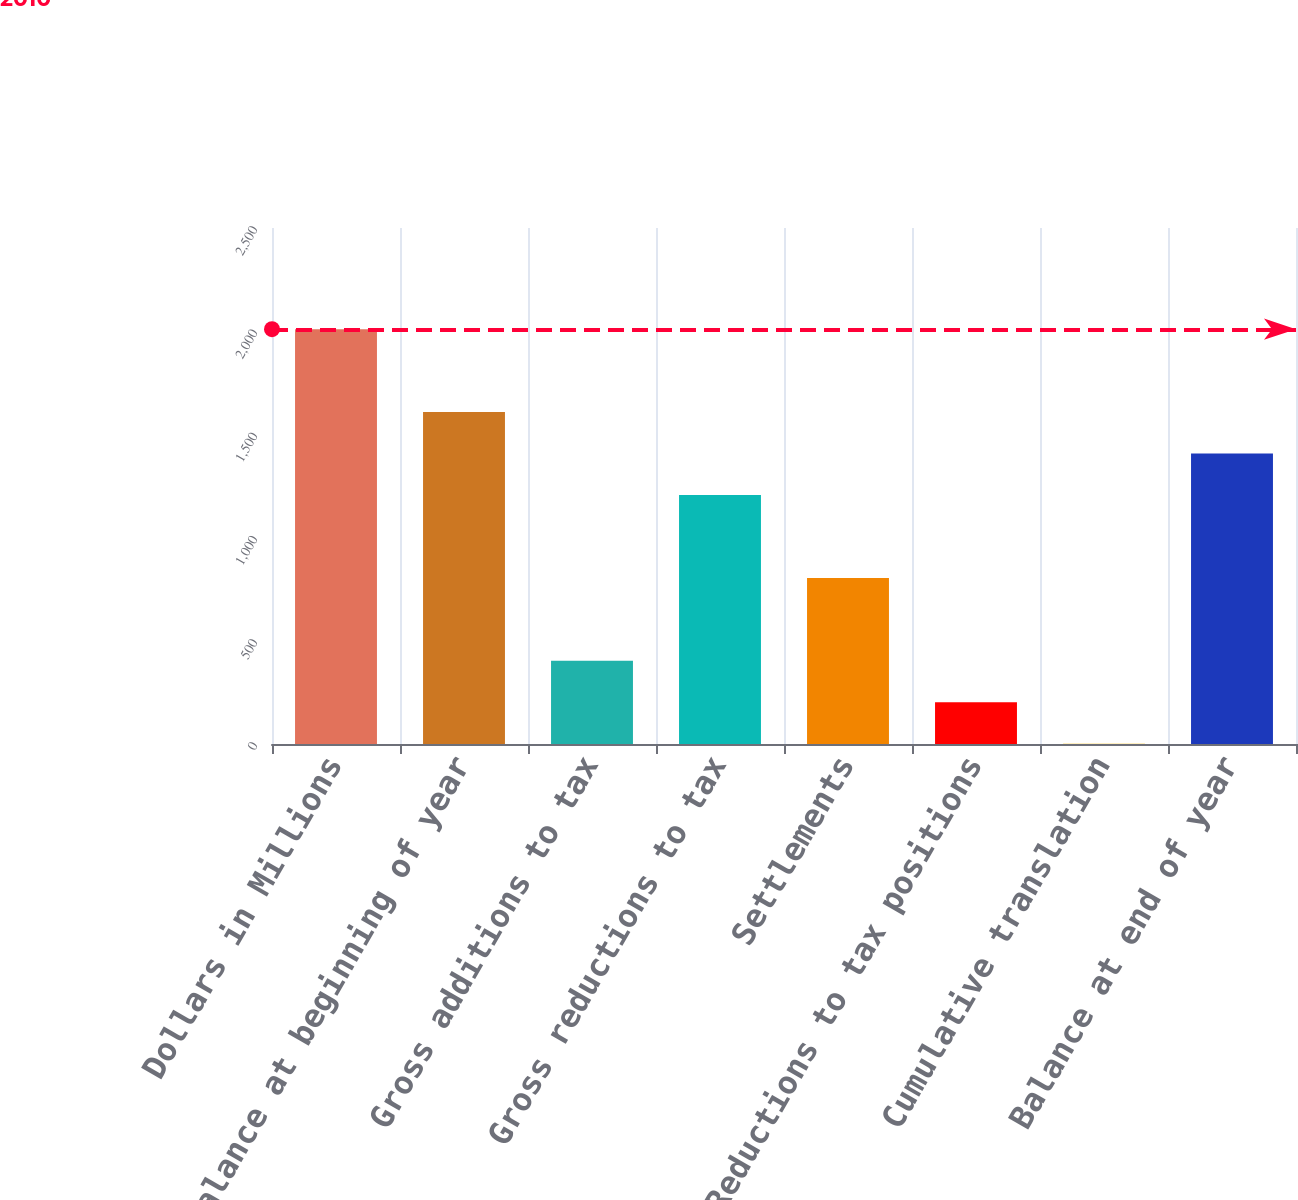<chart> <loc_0><loc_0><loc_500><loc_500><bar_chart><fcel>Dollars in Millions<fcel>Balance at beginning of year<fcel>Gross additions to tax<fcel>Gross reductions to tax<fcel>Settlements<fcel>Reductions to tax positions<fcel>Cumulative translation<fcel>Balance at end of year<nl><fcel>2010<fcel>1608.2<fcel>402.8<fcel>1206.4<fcel>804.6<fcel>201.9<fcel>1<fcel>1407.3<nl></chart> 